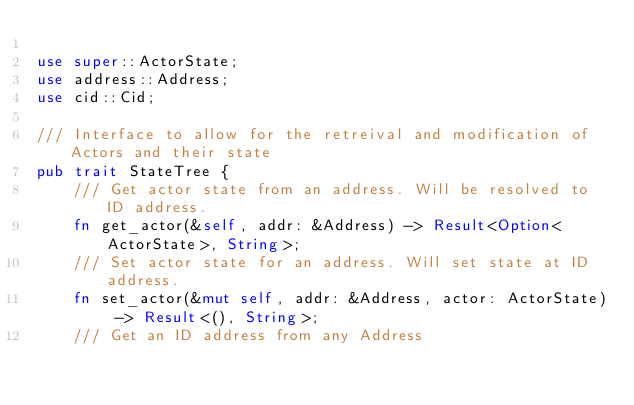<code> <loc_0><loc_0><loc_500><loc_500><_Rust_>
use super::ActorState;
use address::Address;
use cid::Cid;

/// Interface to allow for the retreival and modification of Actors and their state
pub trait StateTree {
    /// Get actor state from an address. Will be resolved to ID address.
    fn get_actor(&self, addr: &Address) -> Result<Option<ActorState>, String>;
    /// Set actor state for an address. Will set state at ID address.
    fn set_actor(&mut self, addr: &Address, actor: ActorState) -> Result<(), String>;
    /// Get an ID address from any Address</code> 